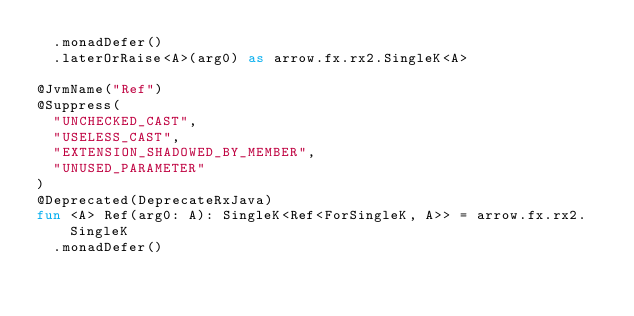<code> <loc_0><loc_0><loc_500><loc_500><_Kotlin_>  .monadDefer()
  .laterOrRaise<A>(arg0) as arrow.fx.rx2.SingleK<A>

@JvmName("Ref")
@Suppress(
  "UNCHECKED_CAST",
  "USELESS_CAST",
  "EXTENSION_SHADOWED_BY_MEMBER",
  "UNUSED_PARAMETER"
)
@Deprecated(DeprecateRxJava)
fun <A> Ref(arg0: A): SingleK<Ref<ForSingleK, A>> = arrow.fx.rx2.SingleK
  .monadDefer()</code> 